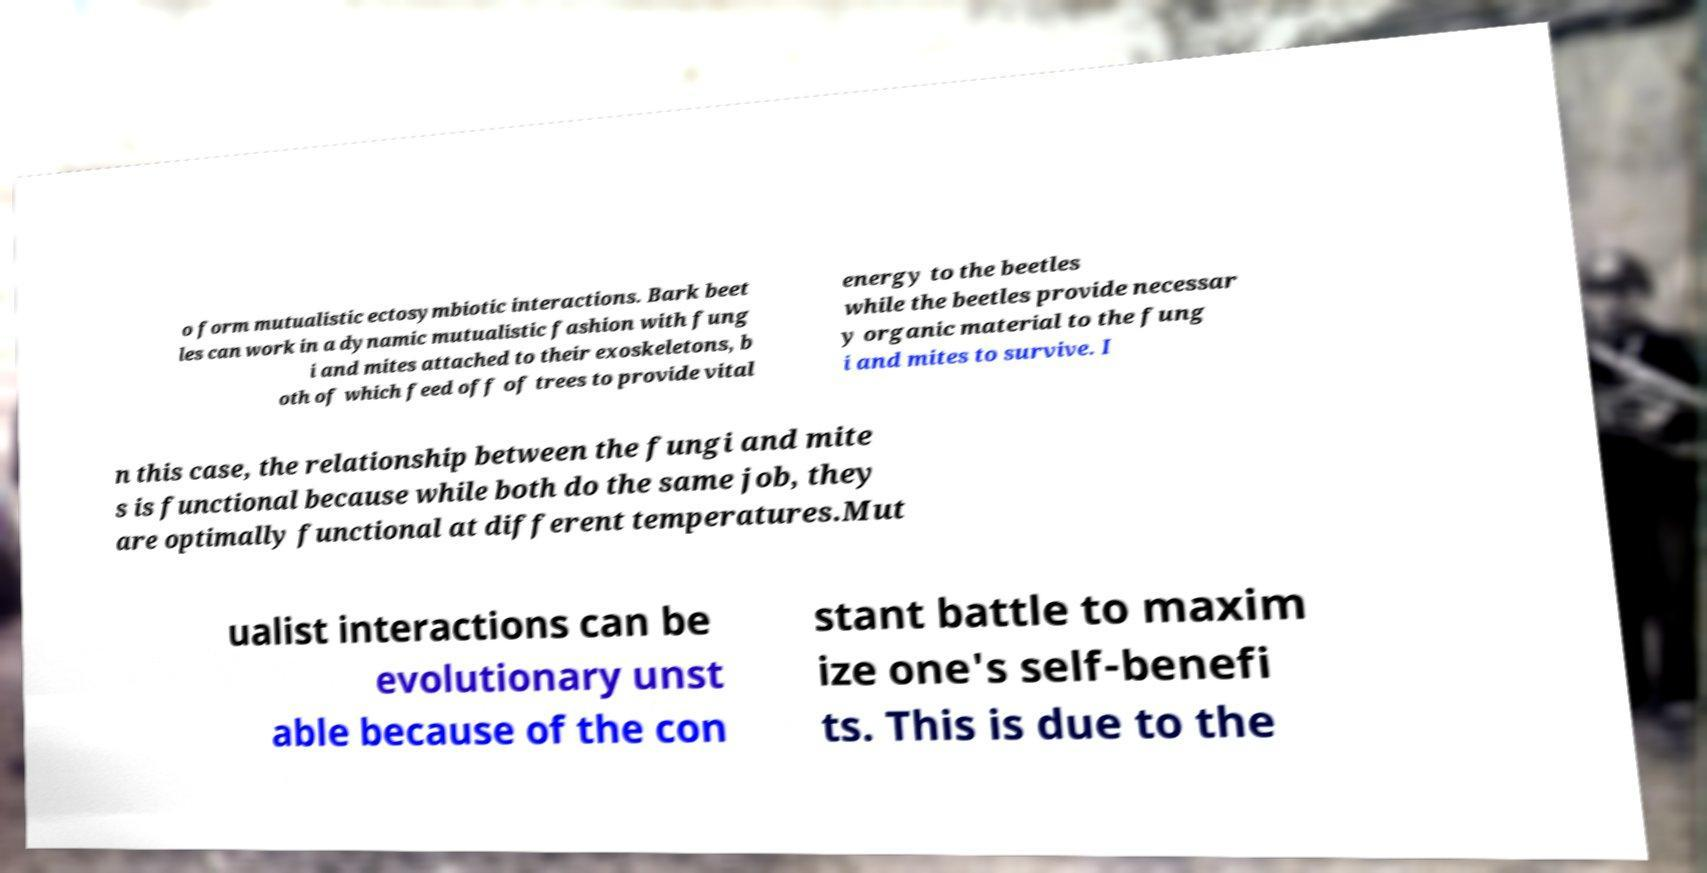What messages or text are displayed in this image? I need them in a readable, typed format. o form mutualistic ectosymbiotic interactions. Bark beet les can work in a dynamic mutualistic fashion with fung i and mites attached to their exoskeletons, b oth of which feed off of trees to provide vital energy to the beetles while the beetles provide necessar y organic material to the fung i and mites to survive. I n this case, the relationship between the fungi and mite s is functional because while both do the same job, they are optimally functional at different temperatures.Mut ualist interactions can be evolutionary unst able because of the con stant battle to maxim ize one's self-benefi ts. This is due to the 